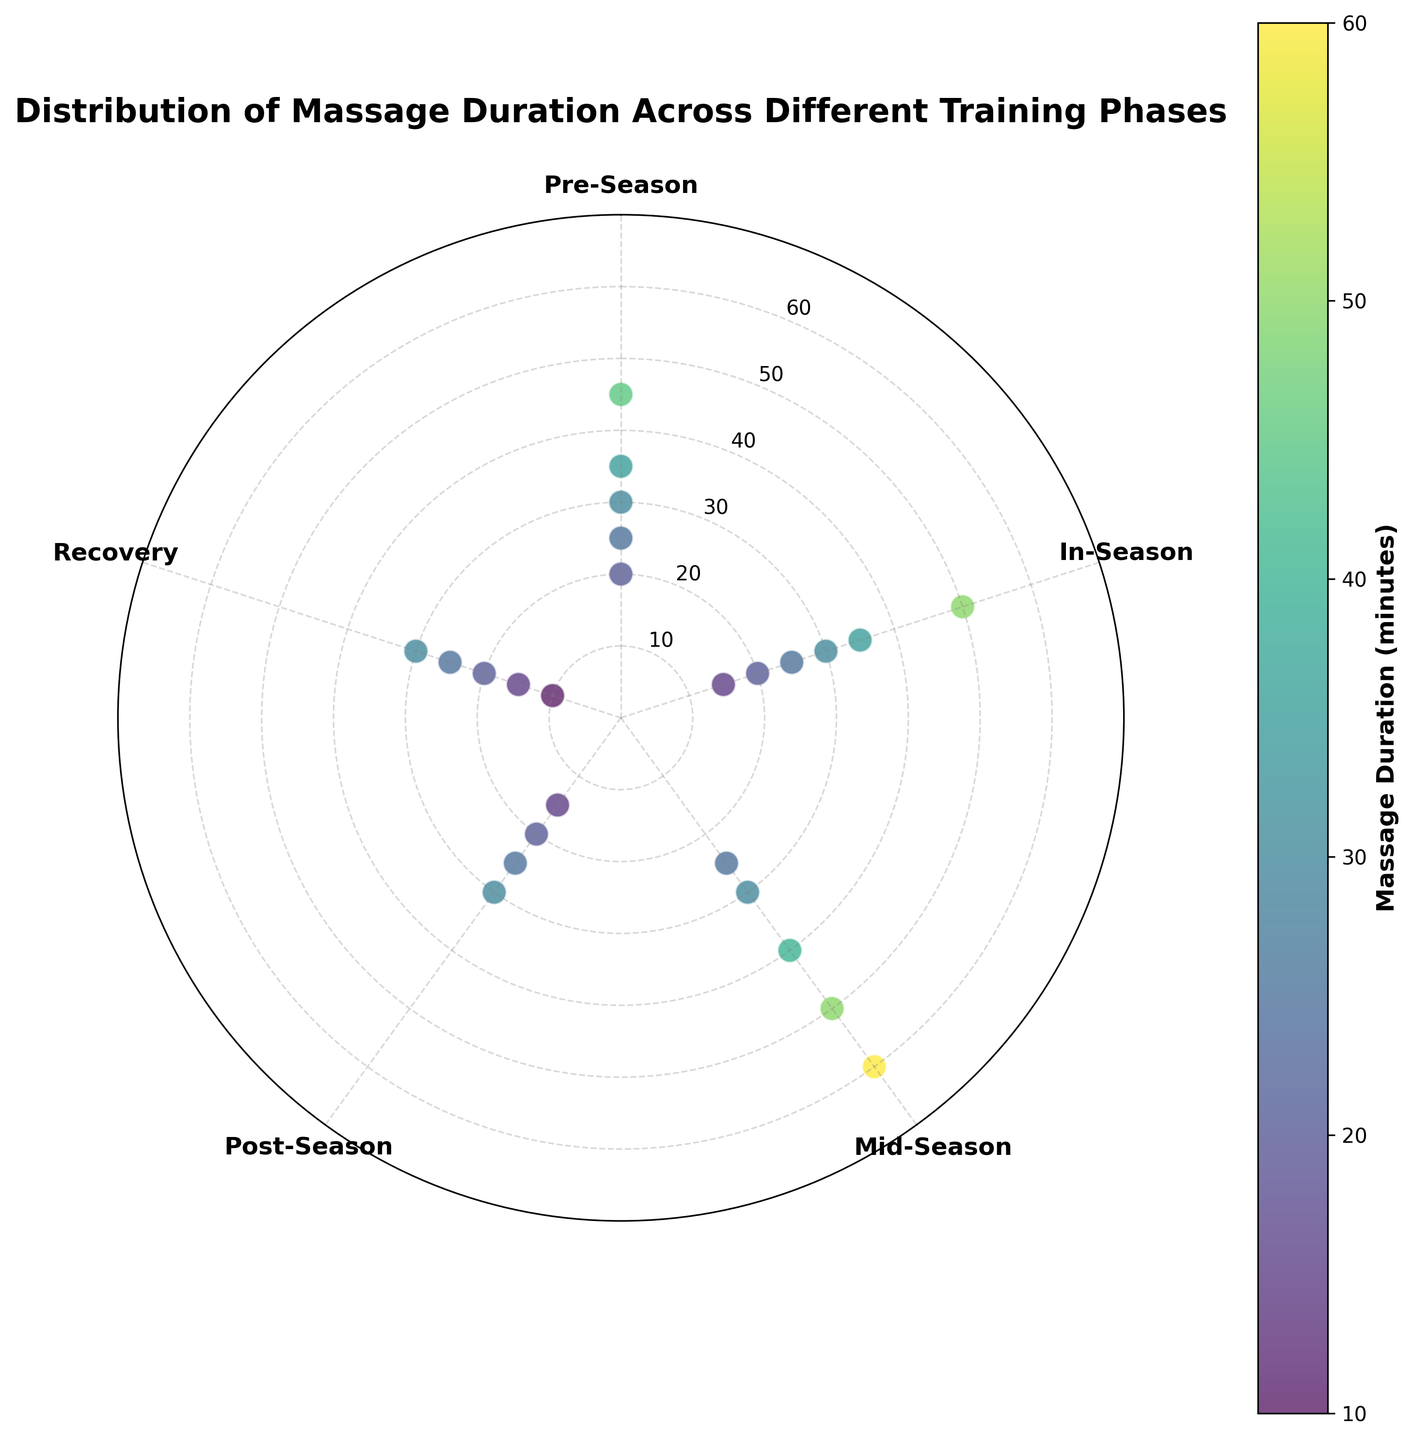What is the title of the Polar Scatter Chart? The title of the Polar Scatter Chart is displayed at the top of the figure, and it describes the main theme or subject of the plot.
Answer: Distribution of Massage Duration Across Different Training Phases Which training phase has the highest massage duration recorded? To identify the phase with the highest massage duration, look for the data point plotted farthest from the center on the scatter plot. This data point corresponds to the highest recorded massage duration.
Answer: Mid-Season What is the range of massage durations in the Pre-Season phase? The range is calculated by finding the difference between the maximum and minimum massage durations within the Pre-Season phase. By observing the scatter points, the values are 20, 30, 45, 25, and 35 minutes. The range is 45 - 20 = 25 minutes.
Answer: 25 minutes How many data points are associated with the In-Season training phase? Count the number of scatter points positioned at the angle representing the In-Season phase on the Polar Scatter Chart.
Answer: 6 Which training phase has the most diverse massage duration? The phase with the most diverse massage duration will have data points spread over the widest range of distances from the center. Observing the chart, Mid-Season has massage durations spanning from 25 to 60 minutes.
Answer: Mid-Season Compare the median massage duration between Pre-Season and Post-Season phases. To find the median duration for each phase, list the durations in ascending order and identify the middle value. For Pre-Season: 20, 25, 30, 35, 45 (median is 30). For Post-Season: 15, 20, 25, 30 (median is (20+25)/2 = 22.5). Therefore, the median for Pre-Season is higher.
Answer: Pre-Season has a higher median Which phase has the lowest median massage duration? Identify the median duration for each phase and compare them. Pre-Season (30), In-Season (25), Mid-Season (40), Post-Season (22.5), and Recovery (20). The lowest median duration is in the Recovery phase.
Answer: Recovery Is there any phase where massage durations appear in only multiples of 5 minutes? Examine the scatter points for each phase and check if their durations primarily end in 0 or 5. Phases Mid-Season = 25, 30, 40, 50, 60 and Recovery = 10, 15, 20, 25, 30 fit this criterion. Mid-Season does not fully fit as it has a single deviation (20). Therefore, Recovery meets the criterion better.
Answer: Recovery What are the most frequent massage durations across all training phases? Identify the durations repeated across different phases by observing and counting scatter points clustered at similar distances from the center across phases. The most frequent durations are 20, 25, and 30 minutes.
Answer: 20, 25, and 30 minutes 